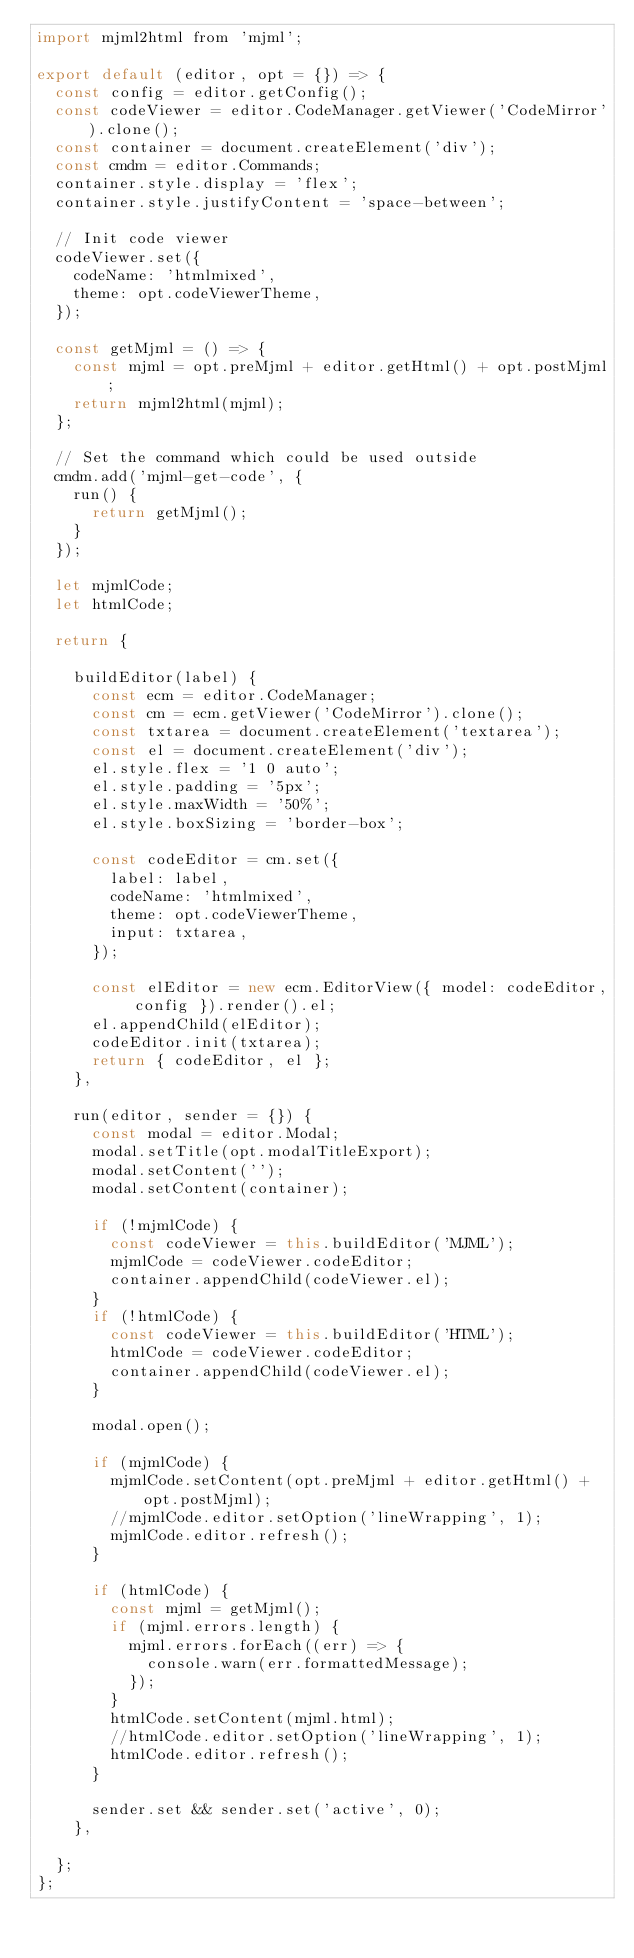<code> <loc_0><loc_0><loc_500><loc_500><_JavaScript_>import mjml2html from 'mjml';

export default (editor, opt = {}) => {
  const config = editor.getConfig();
  const codeViewer = editor.CodeManager.getViewer('CodeMirror').clone();
  const container = document.createElement('div');
  const cmdm = editor.Commands;
  container.style.display = 'flex';
  container.style.justifyContent = 'space-between';

  // Init code viewer
  codeViewer.set({
    codeName: 'htmlmixed',
    theme: opt.codeViewerTheme,
  });

  const getMjml = () => {
    const mjml = opt.preMjml + editor.getHtml() + opt.postMjml;
    return mjml2html(mjml);
  };

  // Set the command which could be used outside
  cmdm.add('mjml-get-code', {
    run() {
      return getMjml();
    }
  });

  let mjmlCode;
  let htmlCode;

  return {

    buildEditor(label) {
      const ecm = editor.CodeManager;
      const cm = ecm.getViewer('CodeMirror').clone();
      const txtarea = document.createElement('textarea');
      const el = document.createElement('div');
      el.style.flex = '1 0 auto';
      el.style.padding = '5px';
      el.style.maxWidth = '50%';
      el.style.boxSizing = 'border-box';

      const codeEditor = cm.set({
        label: label,
        codeName: 'htmlmixed',
        theme: opt.codeViewerTheme,
        input: txtarea,
      });

      const elEditor = new ecm.EditorView({ model: codeEditor, config }).render().el;
      el.appendChild(elEditor);
      codeEditor.init(txtarea);
      return { codeEditor, el };
    },

    run(editor, sender = {}) {
      const modal = editor.Modal;
      modal.setTitle(opt.modalTitleExport);
      modal.setContent('');
      modal.setContent(container);

      if (!mjmlCode) {
        const codeViewer = this.buildEditor('MJML');
        mjmlCode = codeViewer.codeEditor;
        container.appendChild(codeViewer.el);
      }
      if (!htmlCode) {
        const codeViewer = this.buildEditor('HTML');
        htmlCode = codeViewer.codeEditor;
        container.appendChild(codeViewer.el);
      }

      modal.open();

      if (mjmlCode) {
        mjmlCode.setContent(opt.preMjml + editor.getHtml() + opt.postMjml);
        //mjmlCode.editor.setOption('lineWrapping', 1);
        mjmlCode.editor.refresh();
      }

      if (htmlCode) {
        const mjml = getMjml();
        if (mjml.errors.length) {
          mjml.errors.forEach((err) => {
            console.warn(err.formattedMessage);
          });
        }
        htmlCode.setContent(mjml.html);
        //htmlCode.editor.setOption('lineWrapping', 1);
        htmlCode.editor.refresh();
      }

      sender.set && sender.set('active', 0);
    },

  };
};
</code> 